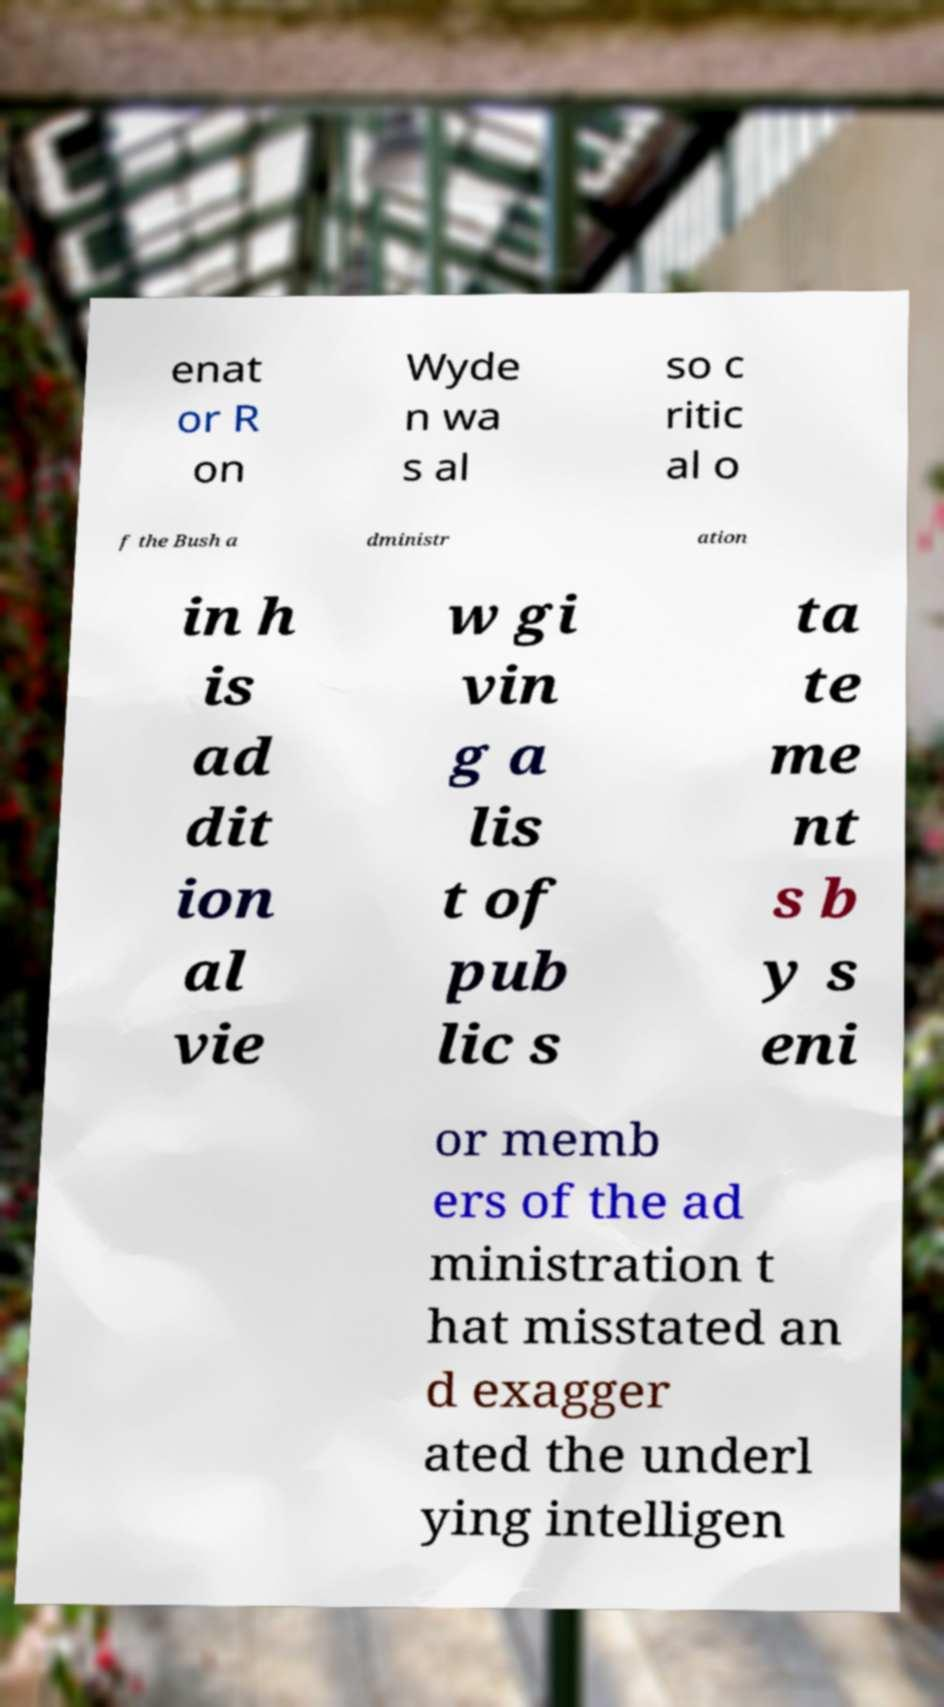There's text embedded in this image that I need extracted. Can you transcribe it verbatim? enat or R on Wyde n wa s al so c ritic al o f the Bush a dministr ation in h is ad dit ion al vie w gi vin g a lis t of pub lic s ta te me nt s b y s eni or memb ers of the ad ministration t hat misstated an d exagger ated the underl ying intelligen 